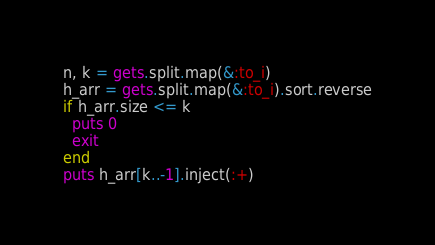Convert code to text. <code><loc_0><loc_0><loc_500><loc_500><_Ruby_>n, k = gets.split.map(&:to_i)
h_arr = gets.split.map(&:to_i).sort.reverse
if h_arr.size <= k
  puts 0
  exit
end
puts h_arr[k..-1].inject(:+)</code> 